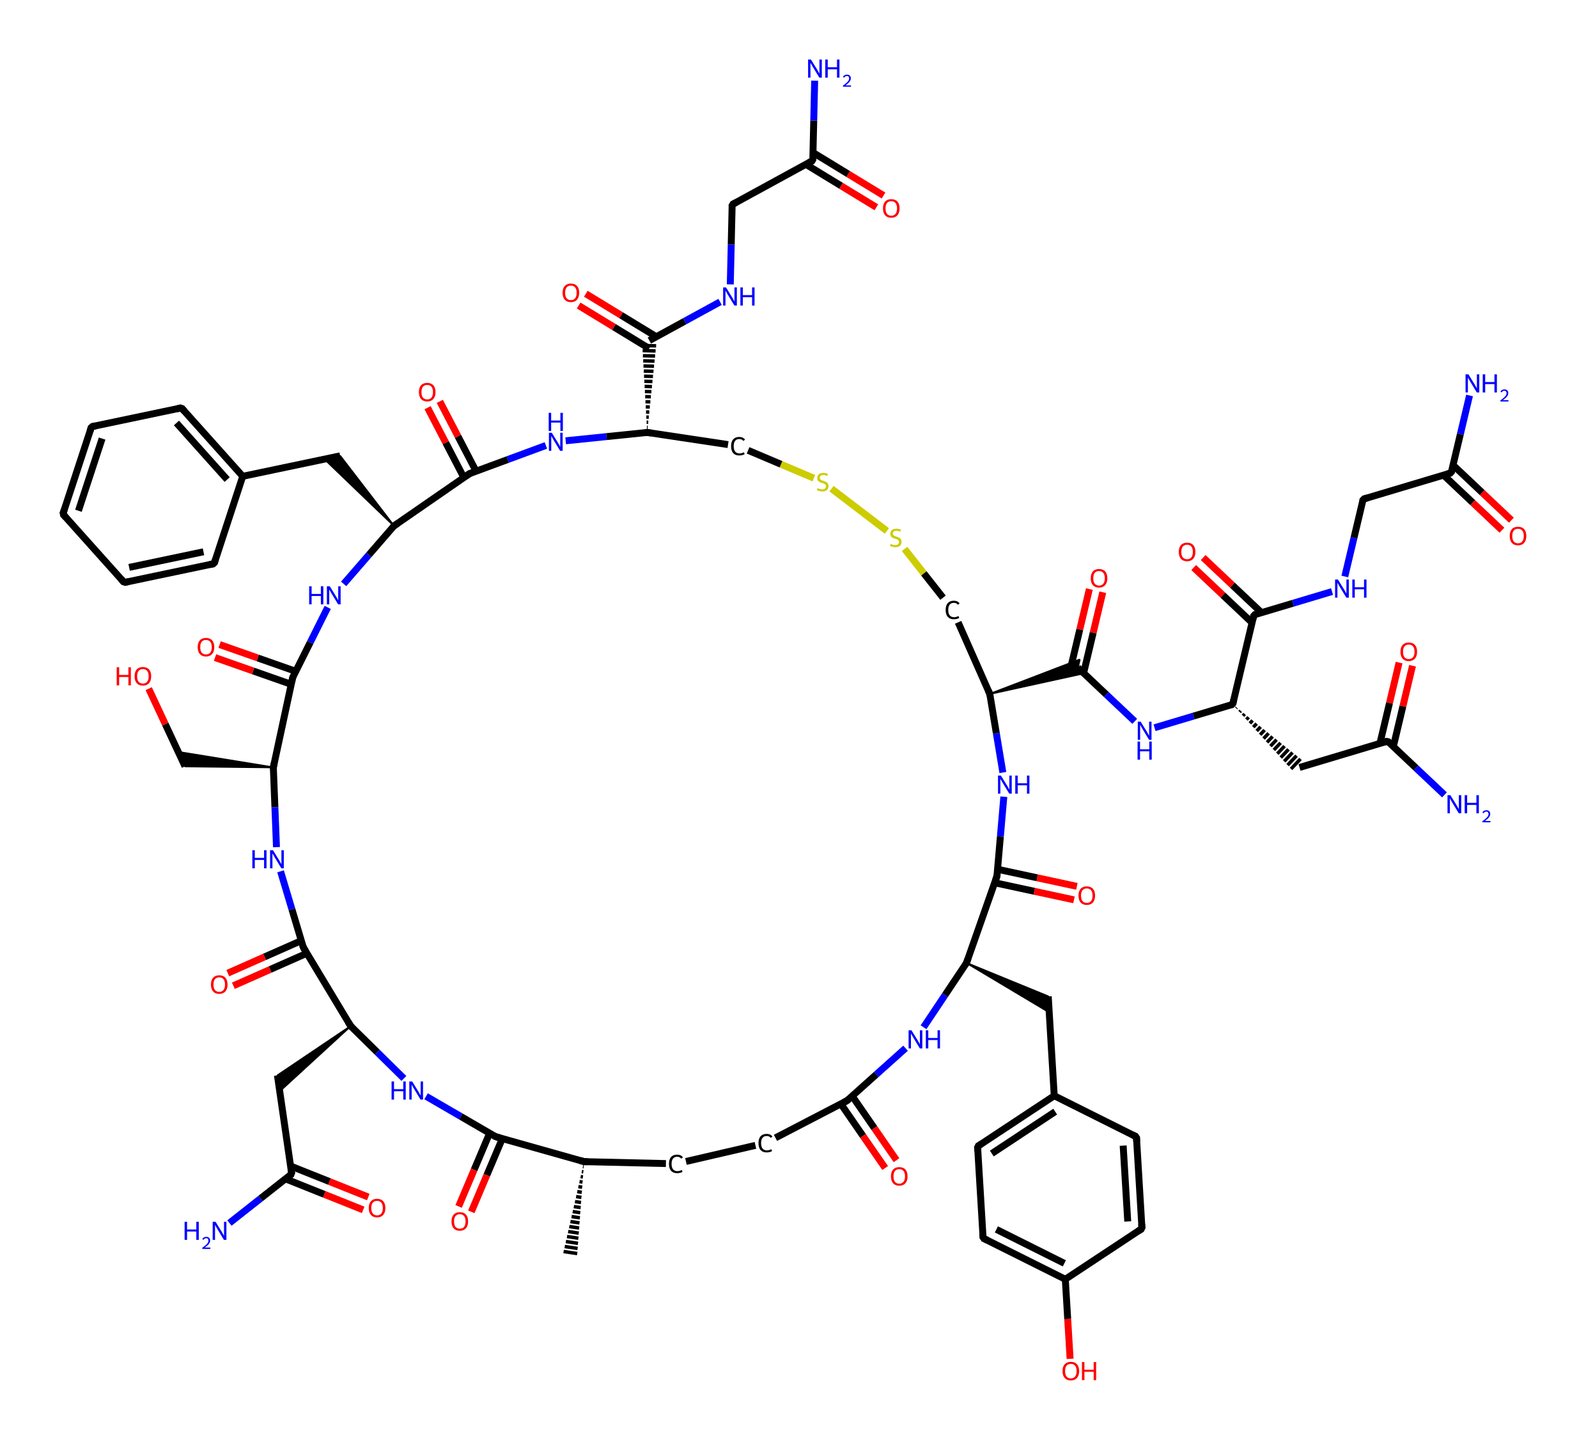How many nitrogen atoms are in this chemical? By examining the SMILES representation, we can identify that nitrogen (N) appears four times throughout the structure. Each occurrence corresponds to one nitrogen atom.
Answer: four What is the functional group present in this hormone? The presence of multiple amide (C(=O)N) and hydroxyl (C-OH) groups in the structure indicates that this chemical belongs to the class of compounds known as hormones due to these functional groups.
Answer: amide and hydroxyl How many rings are present in this chemical structure? A careful analysis of the structure reveals that there are two distinct cyclic structures, which can be observed from the connections made in the SMILES notation indicating ring formation.
Answer: two What is the molecular formula of the chemical? By calculating the number of each atom represented in the SMILES string, we can deduce that the chemical has a molecular formula of C43H66N12O12S2.
Answer: C43H66N12O12S2 How might this hormone influence trust in social interactions? Oxytocin's potential role in social bonding can be inferred from its function as a hormone that promotes feelings of trust and empathy, which are crucial for diplomacy in multicultural environments.
Answer: promotes trust 